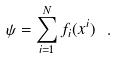Convert formula to latex. <formula><loc_0><loc_0><loc_500><loc_500>\psi = \sum _ { i = 1 } ^ { N } f _ { i } ( x ^ { i } ) \ .</formula> 